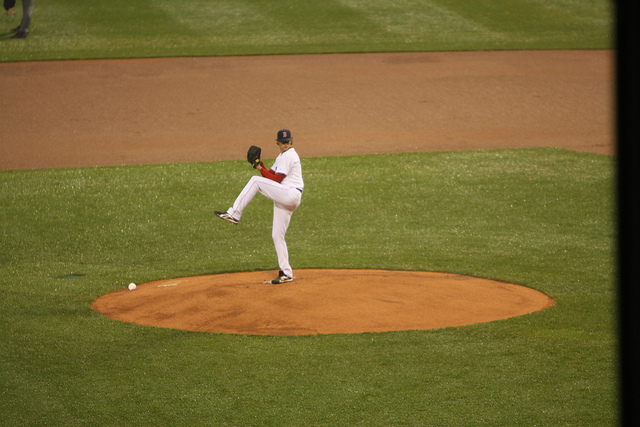<image>What team is the pitcher playing for? I don't know what team the pitcher is playing for. It could be for 'Sox', 'Nationals', 'Cubs', 'Cardinals', 'Yankees' or 'Red Sox'. What team is the pitcher playing for? I don't know what team the pitcher is playing for. It can be seen 'sox', 'nationals', 'red sox', 'cubs', 'cardinals', 'yankees', or 'unclear'. 